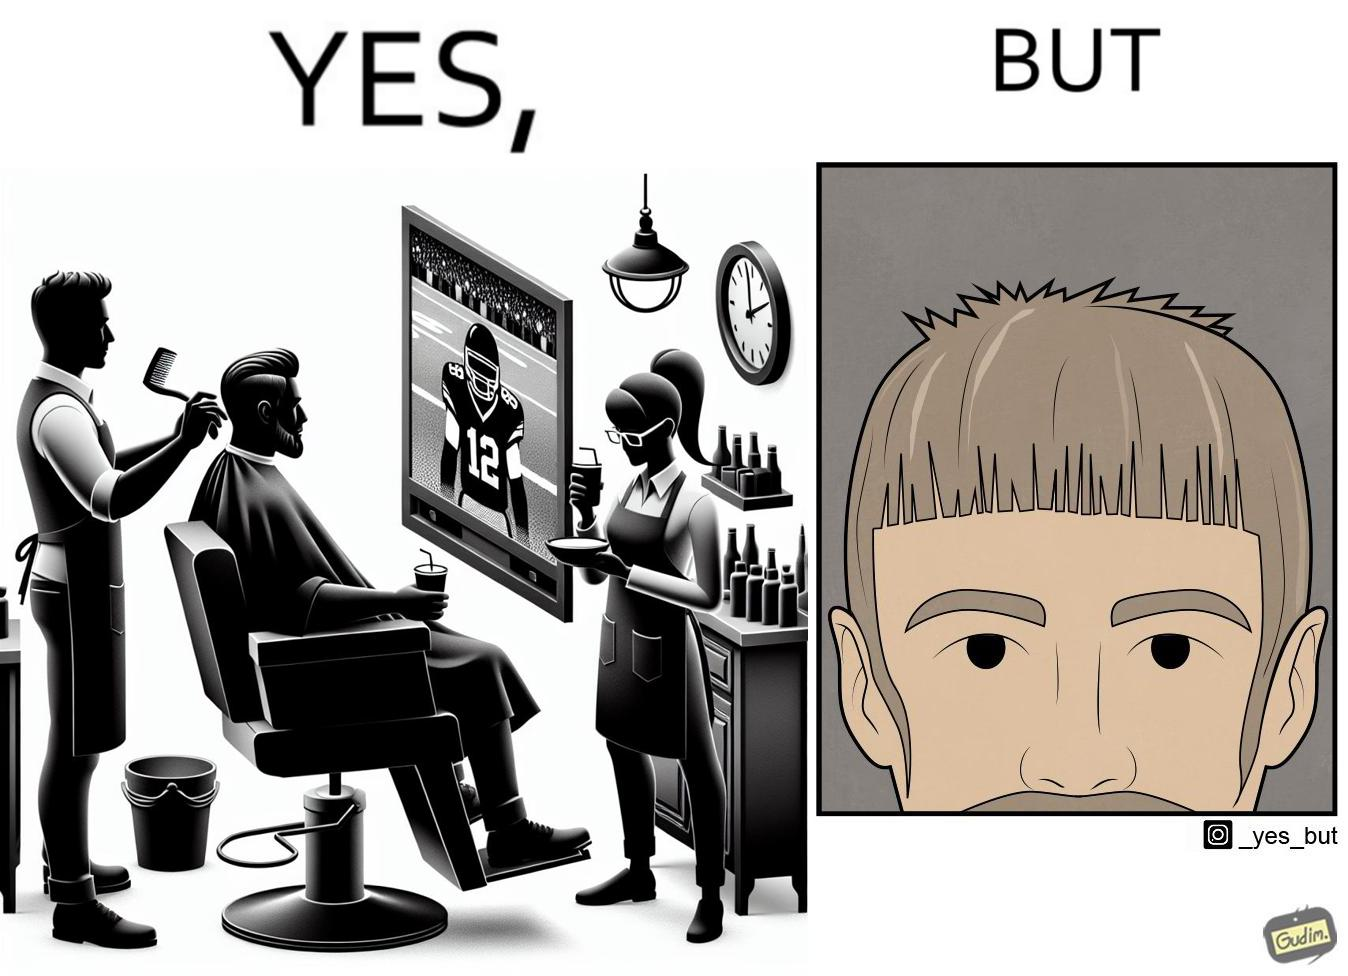Explain why this image is satirical. The image is ironic, because the sole purpose of the person was to get a hair cut but he became so much engrossed in the game that the barber wasn't able to cut his hairs properly. and even the saloon is providing so many facilities but they don't have a good hairdresser 